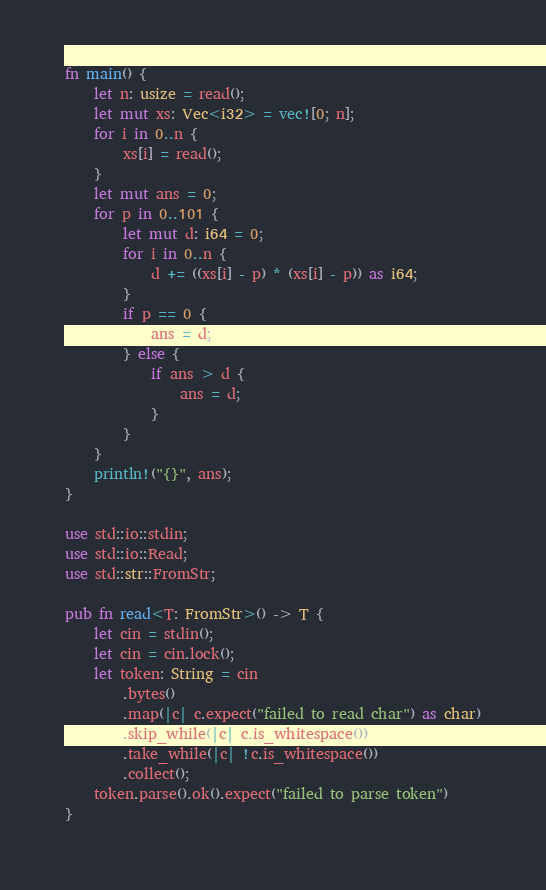Convert code to text. <code><loc_0><loc_0><loc_500><loc_500><_Rust_>fn main() {
    let n: usize = read();
    let mut xs: Vec<i32> = vec![0; n];
    for i in 0..n {
        xs[i] = read();
    }
    let mut ans = 0;
    for p in 0..101 {
        let mut d: i64 = 0;
        for i in 0..n {
            d += ((xs[i] - p) * (xs[i] - p)) as i64;
        }
        if p == 0 {
            ans = d;
        } else {
            if ans > d {
                ans = d;
            }
        }
    }
    println!("{}", ans);
}

use std::io::stdin;
use std::io::Read;
use std::str::FromStr;

pub fn read<T: FromStr>() -> T {
    let cin = stdin();
    let cin = cin.lock();
    let token: String = cin
        .bytes()
        .map(|c| c.expect("failed to read char") as char)
        .skip_while(|c| c.is_whitespace())
        .take_while(|c| !c.is_whitespace())
        .collect();
    token.parse().ok().expect("failed to parse token")
}
</code> 